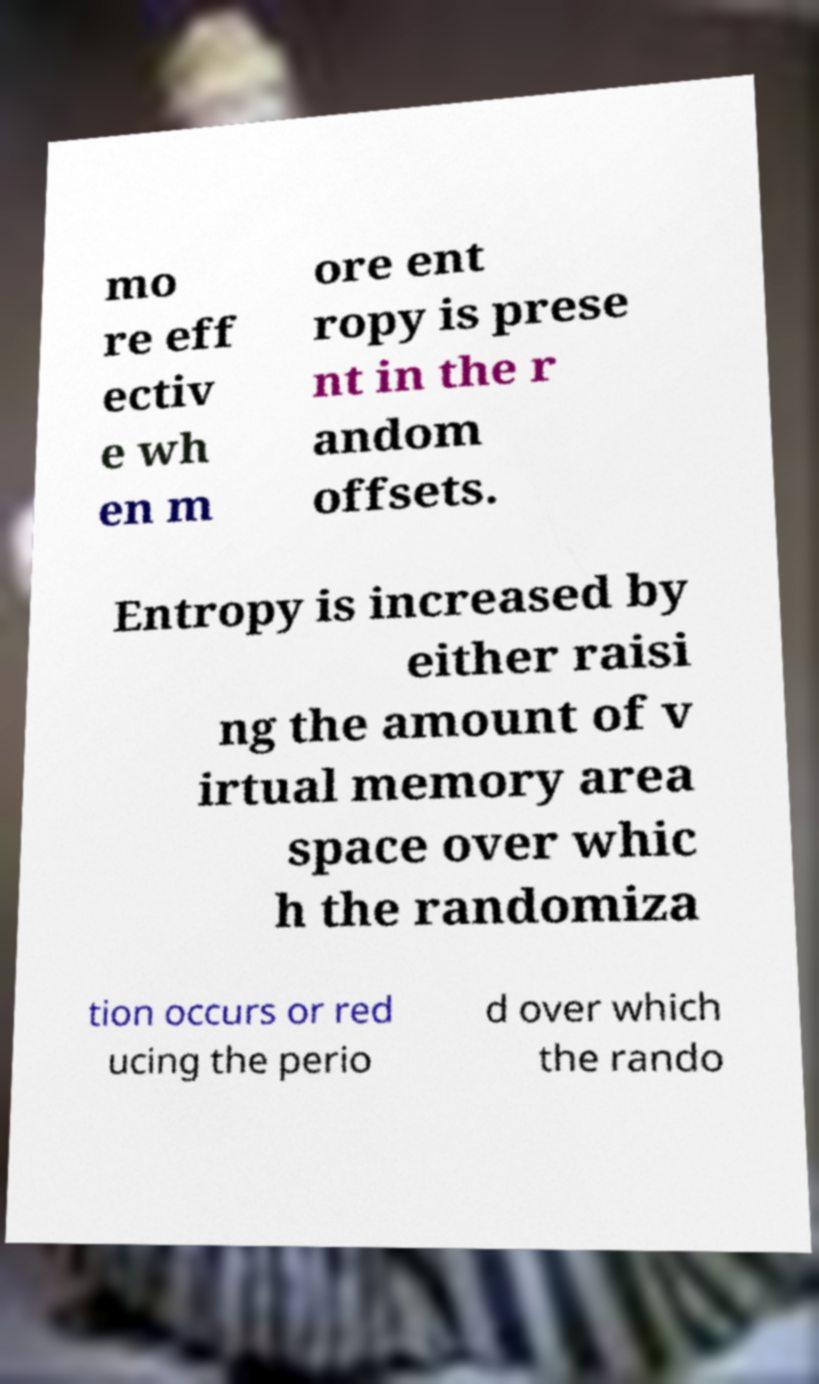I need the written content from this picture converted into text. Can you do that? mo re eff ectiv e wh en m ore ent ropy is prese nt in the r andom offsets. Entropy is increased by either raisi ng the amount of v irtual memory area space over whic h the randomiza tion occurs or red ucing the perio d over which the rando 